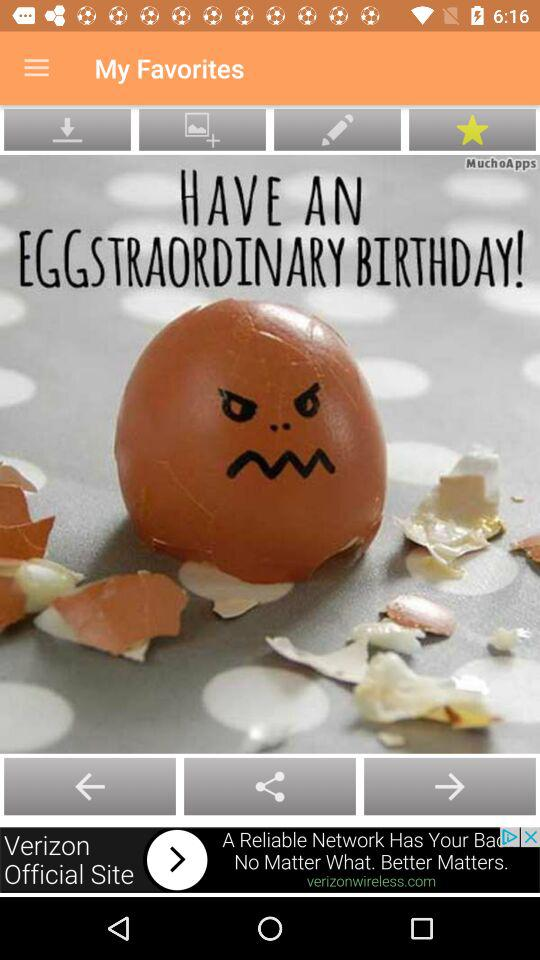What is the name of the application? The name of the application is "My Favorites". 